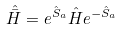Convert formula to latex. <formula><loc_0><loc_0><loc_500><loc_500>\hat { \bar { H } } = e ^ { \hat { S } _ { a } } \hat { H } e ^ { - \hat { S } _ { a } }</formula> 